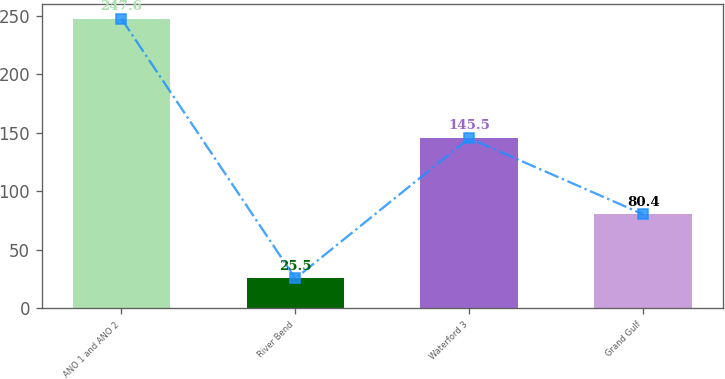Convert chart. <chart><loc_0><loc_0><loc_500><loc_500><bar_chart><fcel>ANO 1 and ANO 2<fcel>River Bend<fcel>Waterford 3<fcel>Grand Gulf<nl><fcel>247.6<fcel>25.5<fcel>145.5<fcel>80.4<nl></chart> 